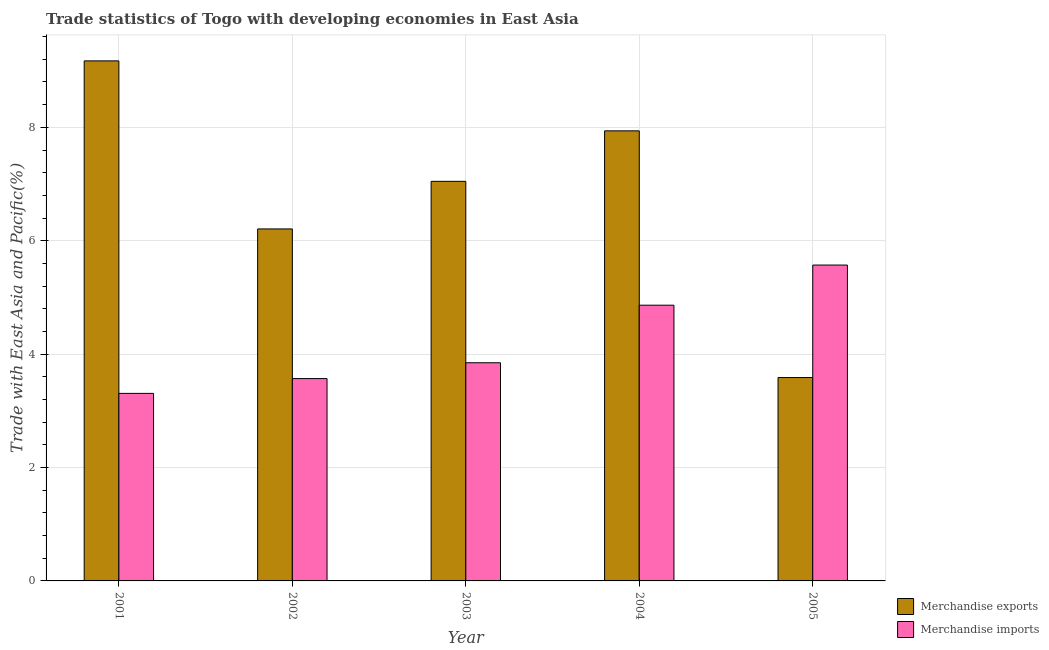How many bars are there on the 4th tick from the left?
Offer a terse response. 2. How many bars are there on the 5th tick from the right?
Provide a short and direct response. 2. What is the label of the 1st group of bars from the left?
Your answer should be very brief. 2001. In how many cases, is the number of bars for a given year not equal to the number of legend labels?
Ensure brevity in your answer.  0. What is the merchandise exports in 2001?
Provide a succinct answer. 9.17. Across all years, what is the maximum merchandise imports?
Provide a succinct answer. 5.57. Across all years, what is the minimum merchandise exports?
Offer a very short reply. 3.59. In which year was the merchandise exports maximum?
Your answer should be very brief. 2001. In which year was the merchandise imports minimum?
Ensure brevity in your answer.  2001. What is the total merchandise exports in the graph?
Your answer should be very brief. 33.95. What is the difference between the merchandise imports in 2001 and that in 2003?
Your answer should be very brief. -0.54. What is the difference between the merchandise imports in 2003 and the merchandise exports in 2004?
Ensure brevity in your answer.  -1.02. What is the average merchandise imports per year?
Provide a short and direct response. 4.23. In the year 2005, what is the difference between the merchandise imports and merchandise exports?
Provide a short and direct response. 0. In how many years, is the merchandise exports greater than 8.4 %?
Offer a very short reply. 1. What is the ratio of the merchandise exports in 2002 to that in 2005?
Provide a succinct answer. 1.73. Is the merchandise exports in 2001 less than that in 2005?
Your answer should be very brief. No. Is the difference between the merchandise imports in 2002 and 2005 greater than the difference between the merchandise exports in 2002 and 2005?
Your response must be concise. No. What is the difference between the highest and the second highest merchandise imports?
Keep it short and to the point. 0.71. What is the difference between the highest and the lowest merchandise exports?
Provide a succinct answer. 5.59. Is the sum of the merchandise exports in 2001 and 2004 greater than the maximum merchandise imports across all years?
Make the answer very short. Yes. What does the 1st bar from the left in 2002 represents?
Offer a very short reply. Merchandise exports. How many years are there in the graph?
Give a very brief answer. 5. Does the graph contain grids?
Keep it short and to the point. Yes. Where does the legend appear in the graph?
Ensure brevity in your answer.  Bottom right. How many legend labels are there?
Offer a very short reply. 2. How are the legend labels stacked?
Keep it short and to the point. Vertical. What is the title of the graph?
Give a very brief answer. Trade statistics of Togo with developing economies in East Asia. What is the label or title of the Y-axis?
Give a very brief answer. Trade with East Asia and Pacific(%). What is the Trade with East Asia and Pacific(%) of Merchandise exports in 2001?
Make the answer very short. 9.17. What is the Trade with East Asia and Pacific(%) of Merchandise imports in 2001?
Keep it short and to the point. 3.31. What is the Trade with East Asia and Pacific(%) in Merchandise exports in 2002?
Your answer should be very brief. 6.21. What is the Trade with East Asia and Pacific(%) in Merchandise imports in 2002?
Make the answer very short. 3.57. What is the Trade with East Asia and Pacific(%) in Merchandise exports in 2003?
Your answer should be compact. 7.05. What is the Trade with East Asia and Pacific(%) of Merchandise imports in 2003?
Keep it short and to the point. 3.85. What is the Trade with East Asia and Pacific(%) of Merchandise exports in 2004?
Keep it short and to the point. 7.94. What is the Trade with East Asia and Pacific(%) of Merchandise imports in 2004?
Provide a short and direct response. 4.86. What is the Trade with East Asia and Pacific(%) of Merchandise exports in 2005?
Provide a short and direct response. 3.59. What is the Trade with East Asia and Pacific(%) in Merchandise imports in 2005?
Provide a short and direct response. 5.57. Across all years, what is the maximum Trade with East Asia and Pacific(%) in Merchandise exports?
Keep it short and to the point. 9.17. Across all years, what is the maximum Trade with East Asia and Pacific(%) of Merchandise imports?
Give a very brief answer. 5.57. Across all years, what is the minimum Trade with East Asia and Pacific(%) in Merchandise exports?
Make the answer very short. 3.59. Across all years, what is the minimum Trade with East Asia and Pacific(%) in Merchandise imports?
Make the answer very short. 3.31. What is the total Trade with East Asia and Pacific(%) in Merchandise exports in the graph?
Offer a very short reply. 33.95. What is the total Trade with East Asia and Pacific(%) of Merchandise imports in the graph?
Your answer should be very brief. 21.16. What is the difference between the Trade with East Asia and Pacific(%) of Merchandise exports in 2001 and that in 2002?
Offer a terse response. 2.96. What is the difference between the Trade with East Asia and Pacific(%) of Merchandise imports in 2001 and that in 2002?
Make the answer very short. -0.26. What is the difference between the Trade with East Asia and Pacific(%) of Merchandise exports in 2001 and that in 2003?
Your answer should be very brief. 2.12. What is the difference between the Trade with East Asia and Pacific(%) in Merchandise imports in 2001 and that in 2003?
Keep it short and to the point. -0.54. What is the difference between the Trade with East Asia and Pacific(%) of Merchandise exports in 2001 and that in 2004?
Offer a very short reply. 1.23. What is the difference between the Trade with East Asia and Pacific(%) of Merchandise imports in 2001 and that in 2004?
Your answer should be compact. -1.56. What is the difference between the Trade with East Asia and Pacific(%) of Merchandise exports in 2001 and that in 2005?
Ensure brevity in your answer.  5.59. What is the difference between the Trade with East Asia and Pacific(%) of Merchandise imports in 2001 and that in 2005?
Provide a succinct answer. -2.26. What is the difference between the Trade with East Asia and Pacific(%) of Merchandise exports in 2002 and that in 2003?
Give a very brief answer. -0.84. What is the difference between the Trade with East Asia and Pacific(%) in Merchandise imports in 2002 and that in 2003?
Make the answer very short. -0.28. What is the difference between the Trade with East Asia and Pacific(%) of Merchandise exports in 2002 and that in 2004?
Keep it short and to the point. -1.73. What is the difference between the Trade with East Asia and Pacific(%) in Merchandise imports in 2002 and that in 2004?
Provide a short and direct response. -1.29. What is the difference between the Trade with East Asia and Pacific(%) in Merchandise exports in 2002 and that in 2005?
Give a very brief answer. 2.62. What is the difference between the Trade with East Asia and Pacific(%) of Merchandise imports in 2002 and that in 2005?
Offer a terse response. -2. What is the difference between the Trade with East Asia and Pacific(%) of Merchandise exports in 2003 and that in 2004?
Ensure brevity in your answer.  -0.89. What is the difference between the Trade with East Asia and Pacific(%) of Merchandise imports in 2003 and that in 2004?
Give a very brief answer. -1.02. What is the difference between the Trade with East Asia and Pacific(%) in Merchandise exports in 2003 and that in 2005?
Your response must be concise. 3.46. What is the difference between the Trade with East Asia and Pacific(%) in Merchandise imports in 2003 and that in 2005?
Your answer should be very brief. -1.72. What is the difference between the Trade with East Asia and Pacific(%) of Merchandise exports in 2004 and that in 2005?
Provide a succinct answer. 4.35. What is the difference between the Trade with East Asia and Pacific(%) of Merchandise imports in 2004 and that in 2005?
Offer a very short reply. -0.71. What is the difference between the Trade with East Asia and Pacific(%) in Merchandise exports in 2001 and the Trade with East Asia and Pacific(%) in Merchandise imports in 2002?
Offer a very short reply. 5.6. What is the difference between the Trade with East Asia and Pacific(%) in Merchandise exports in 2001 and the Trade with East Asia and Pacific(%) in Merchandise imports in 2003?
Offer a very short reply. 5.32. What is the difference between the Trade with East Asia and Pacific(%) of Merchandise exports in 2001 and the Trade with East Asia and Pacific(%) of Merchandise imports in 2004?
Offer a very short reply. 4.31. What is the difference between the Trade with East Asia and Pacific(%) of Merchandise exports in 2001 and the Trade with East Asia and Pacific(%) of Merchandise imports in 2005?
Offer a very short reply. 3.6. What is the difference between the Trade with East Asia and Pacific(%) of Merchandise exports in 2002 and the Trade with East Asia and Pacific(%) of Merchandise imports in 2003?
Your answer should be compact. 2.36. What is the difference between the Trade with East Asia and Pacific(%) in Merchandise exports in 2002 and the Trade with East Asia and Pacific(%) in Merchandise imports in 2004?
Ensure brevity in your answer.  1.35. What is the difference between the Trade with East Asia and Pacific(%) of Merchandise exports in 2002 and the Trade with East Asia and Pacific(%) of Merchandise imports in 2005?
Provide a succinct answer. 0.64. What is the difference between the Trade with East Asia and Pacific(%) in Merchandise exports in 2003 and the Trade with East Asia and Pacific(%) in Merchandise imports in 2004?
Offer a very short reply. 2.18. What is the difference between the Trade with East Asia and Pacific(%) of Merchandise exports in 2003 and the Trade with East Asia and Pacific(%) of Merchandise imports in 2005?
Offer a very short reply. 1.48. What is the difference between the Trade with East Asia and Pacific(%) of Merchandise exports in 2004 and the Trade with East Asia and Pacific(%) of Merchandise imports in 2005?
Offer a very short reply. 2.37. What is the average Trade with East Asia and Pacific(%) in Merchandise exports per year?
Your answer should be very brief. 6.79. What is the average Trade with East Asia and Pacific(%) of Merchandise imports per year?
Your response must be concise. 4.23. In the year 2001, what is the difference between the Trade with East Asia and Pacific(%) of Merchandise exports and Trade with East Asia and Pacific(%) of Merchandise imports?
Give a very brief answer. 5.86. In the year 2002, what is the difference between the Trade with East Asia and Pacific(%) of Merchandise exports and Trade with East Asia and Pacific(%) of Merchandise imports?
Make the answer very short. 2.64. In the year 2004, what is the difference between the Trade with East Asia and Pacific(%) of Merchandise exports and Trade with East Asia and Pacific(%) of Merchandise imports?
Offer a very short reply. 3.08. In the year 2005, what is the difference between the Trade with East Asia and Pacific(%) in Merchandise exports and Trade with East Asia and Pacific(%) in Merchandise imports?
Provide a short and direct response. -1.98. What is the ratio of the Trade with East Asia and Pacific(%) in Merchandise exports in 2001 to that in 2002?
Your answer should be compact. 1.48. What is the ratio of the Trade with East Asia and Pacific(%) in Merchandise imports in 2001 to that in 2002?
Offer a terse response. 0.93. What is the ratio of the Trade with East Asia and Pacific(%) in Merchandise exports in 2001 to that in 2003?
Offer a terse response. 1.3. What is the ratio of the Trade with East Asia and Pacific(%) of Merchandise imports in 2001 to that in 2003?
Offer a terse response. 0.86. What is the ratio of the Trade with East Asia and Pacific(%) in Merchandise exports in 2001 to that in 2004?
Give a very brief answer. 1.16. What is the ratio of the Trade with East Asia and Pacific(%) in Merchandise imports in 2001 to that in 2004?
Your answer should be very brief. 0.68. What is the ratio of the Trade with East Asia and Pacific(%) in Merchandise exports in 2001 to that in 2005?
Your response must be concise. 2.56. What is the ratio of the Trade with East Asia and Pacific(%) in Merchandise imports in 2001 to that in 2005?
Keep it short and to the point. 0.59. What is the ratio of the Trade with East Asia and Pacific(%) of Merchandise exports in 2002 to that in 2003?
Your answer should be very brief. 0.88. What is the ratio of the Trade with East Asia and Pacific(%) in Merchandise imports in 2002 to that in 2003?
Make the answer very short. 0.93. What is the ratio of the Trade with East Asia and Pacific(%) in Merchandise exports in 2002 to that in 2004?
Make the answer very short. 0.78. What is the ratio of the Trade with East Asia and Pacific(%) in Merchandise imports in 2002 to that in 2004?
Offer a very short reply. 0.73. What is the ratio of the Trade with East Asia and Pacific(%) of Merchandise exports in 2002 to that in 2005?
Provide a short and direct response. 1.73. What is the ratio of the Trade with East Asia and Pacific(%) in Merchandise imports in 2002 to that in 2005?
Ensure brevity in your answer.  0.64. What is the ratio of the Trade with East Asia and Pacific(%) of Merchandise exports in 2003 to that in 2004?
Offer a terse response. 0.89. What is the ratio of the Trade with East Asia and Pacific(%) in Merchandise imports in 2003 to that in 2004?
Offer a terse response. 0.79. What is the ratio of the Trade with East Asia and Pacific(%) of Merchandise exports in 2003 to that in 2005?
Your answer should be compact. 1.96. What is the ratio of the Trade with East Asia and Pacific(%) in Merchandise imports in 2003 to that in 2005?
Your answer should be very brief. 0.69. What is the ratio of the Trade with East Asia and Pacific(%) of Merchandise exports in 2004 to that in 2005?
Provide a succinct answer. 2.21. What is the ratio of the Trade with East Asia and Pacific(%) of Merchandise imports in 2004 to that in 2005?
Your answer should be compact. 0.87. What is the difference between the highest and the second highest Trade with East Asia and Pacific(%) of Merchandise exports?
Make the answer very short. 1.23. What is the difference between the highest and the second highest Trade with East Asia and Pacific(%) of Merchandise imports?
Ensure brevity in your answer.  0.71. What is the difference between the highest and the lowest Trade with East Asia and Pacific(%) of Merchandise exports?
Your answer should be very brief. 5.59. What is the difference between the highest and the lowest Trade with East Asia and Pacific(%) in Merchandise imports?
Provide a succinct answer. 2.26. 